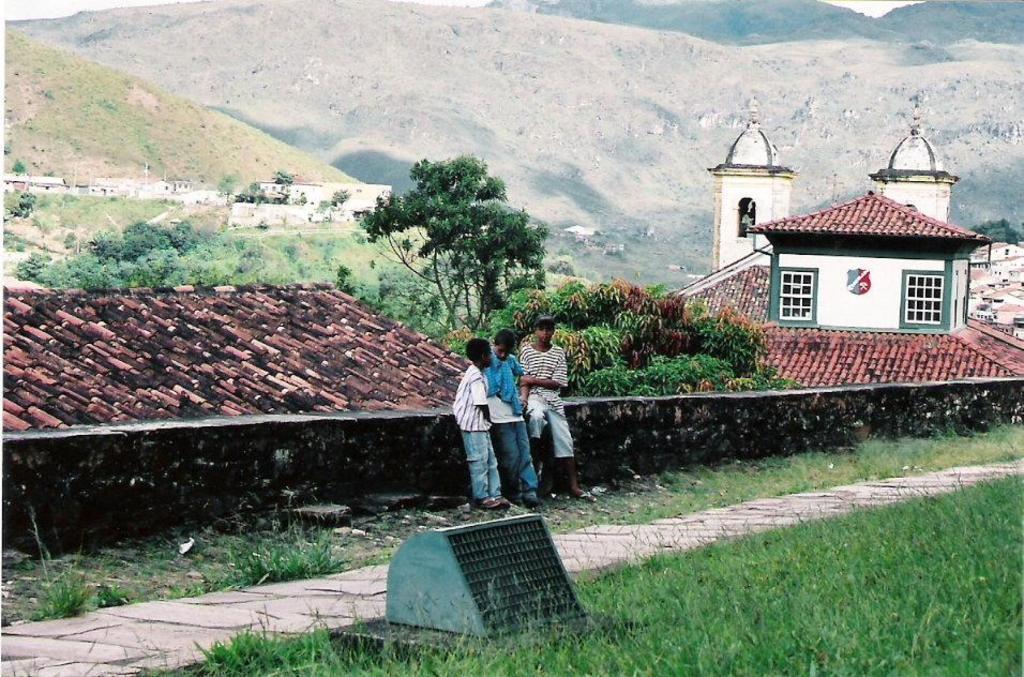Could you give a brief overview of what you see in this image? In the picture I can see three kids are standing on the ground. In the background I can see houses, trees, plants, the grass, the sky and some other objects. 